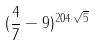Convert formula to latex. <formula><loc_0><loc_0><loc_500><loc_500>( \frac { 4 } { 7 } - 9 ) ^ { 2 0 4 \cdot \sqrt { 5 } }</formula> 